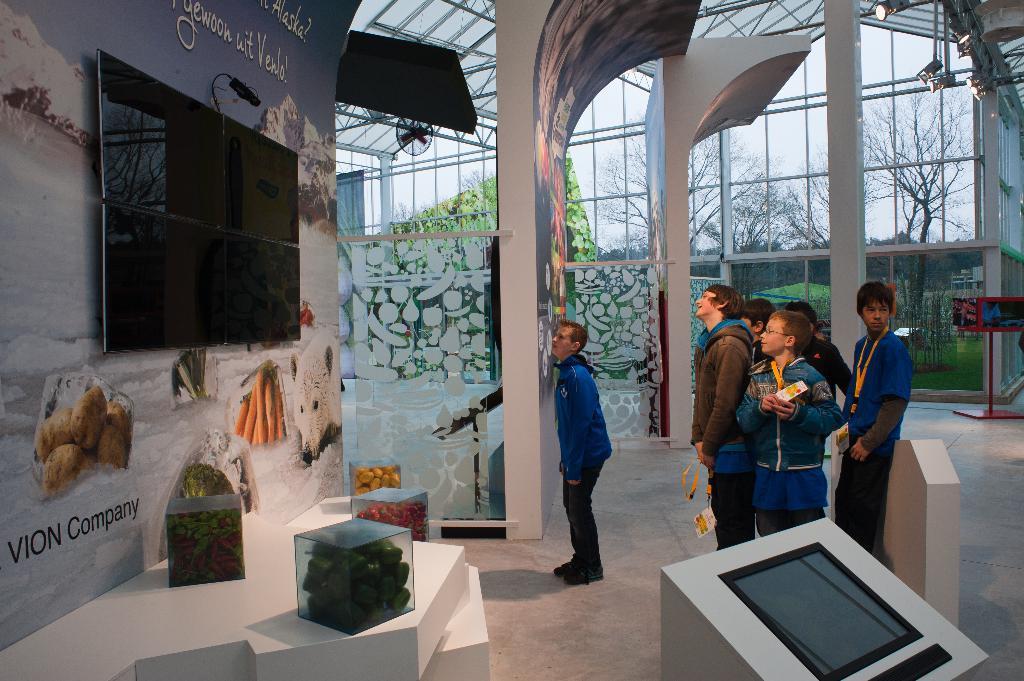Please provide a concise description of this image. In this image, we can see a group of people are standing on the floor. Here we can see some boxes filled with items, vegetables. Here there is a screen. Left side of the image, we can see a banner, screens, camera. Top of the image, there is a roof with glass. Through the glass, we can see the outside view. There are so many trees, plants, grass we can see here. 